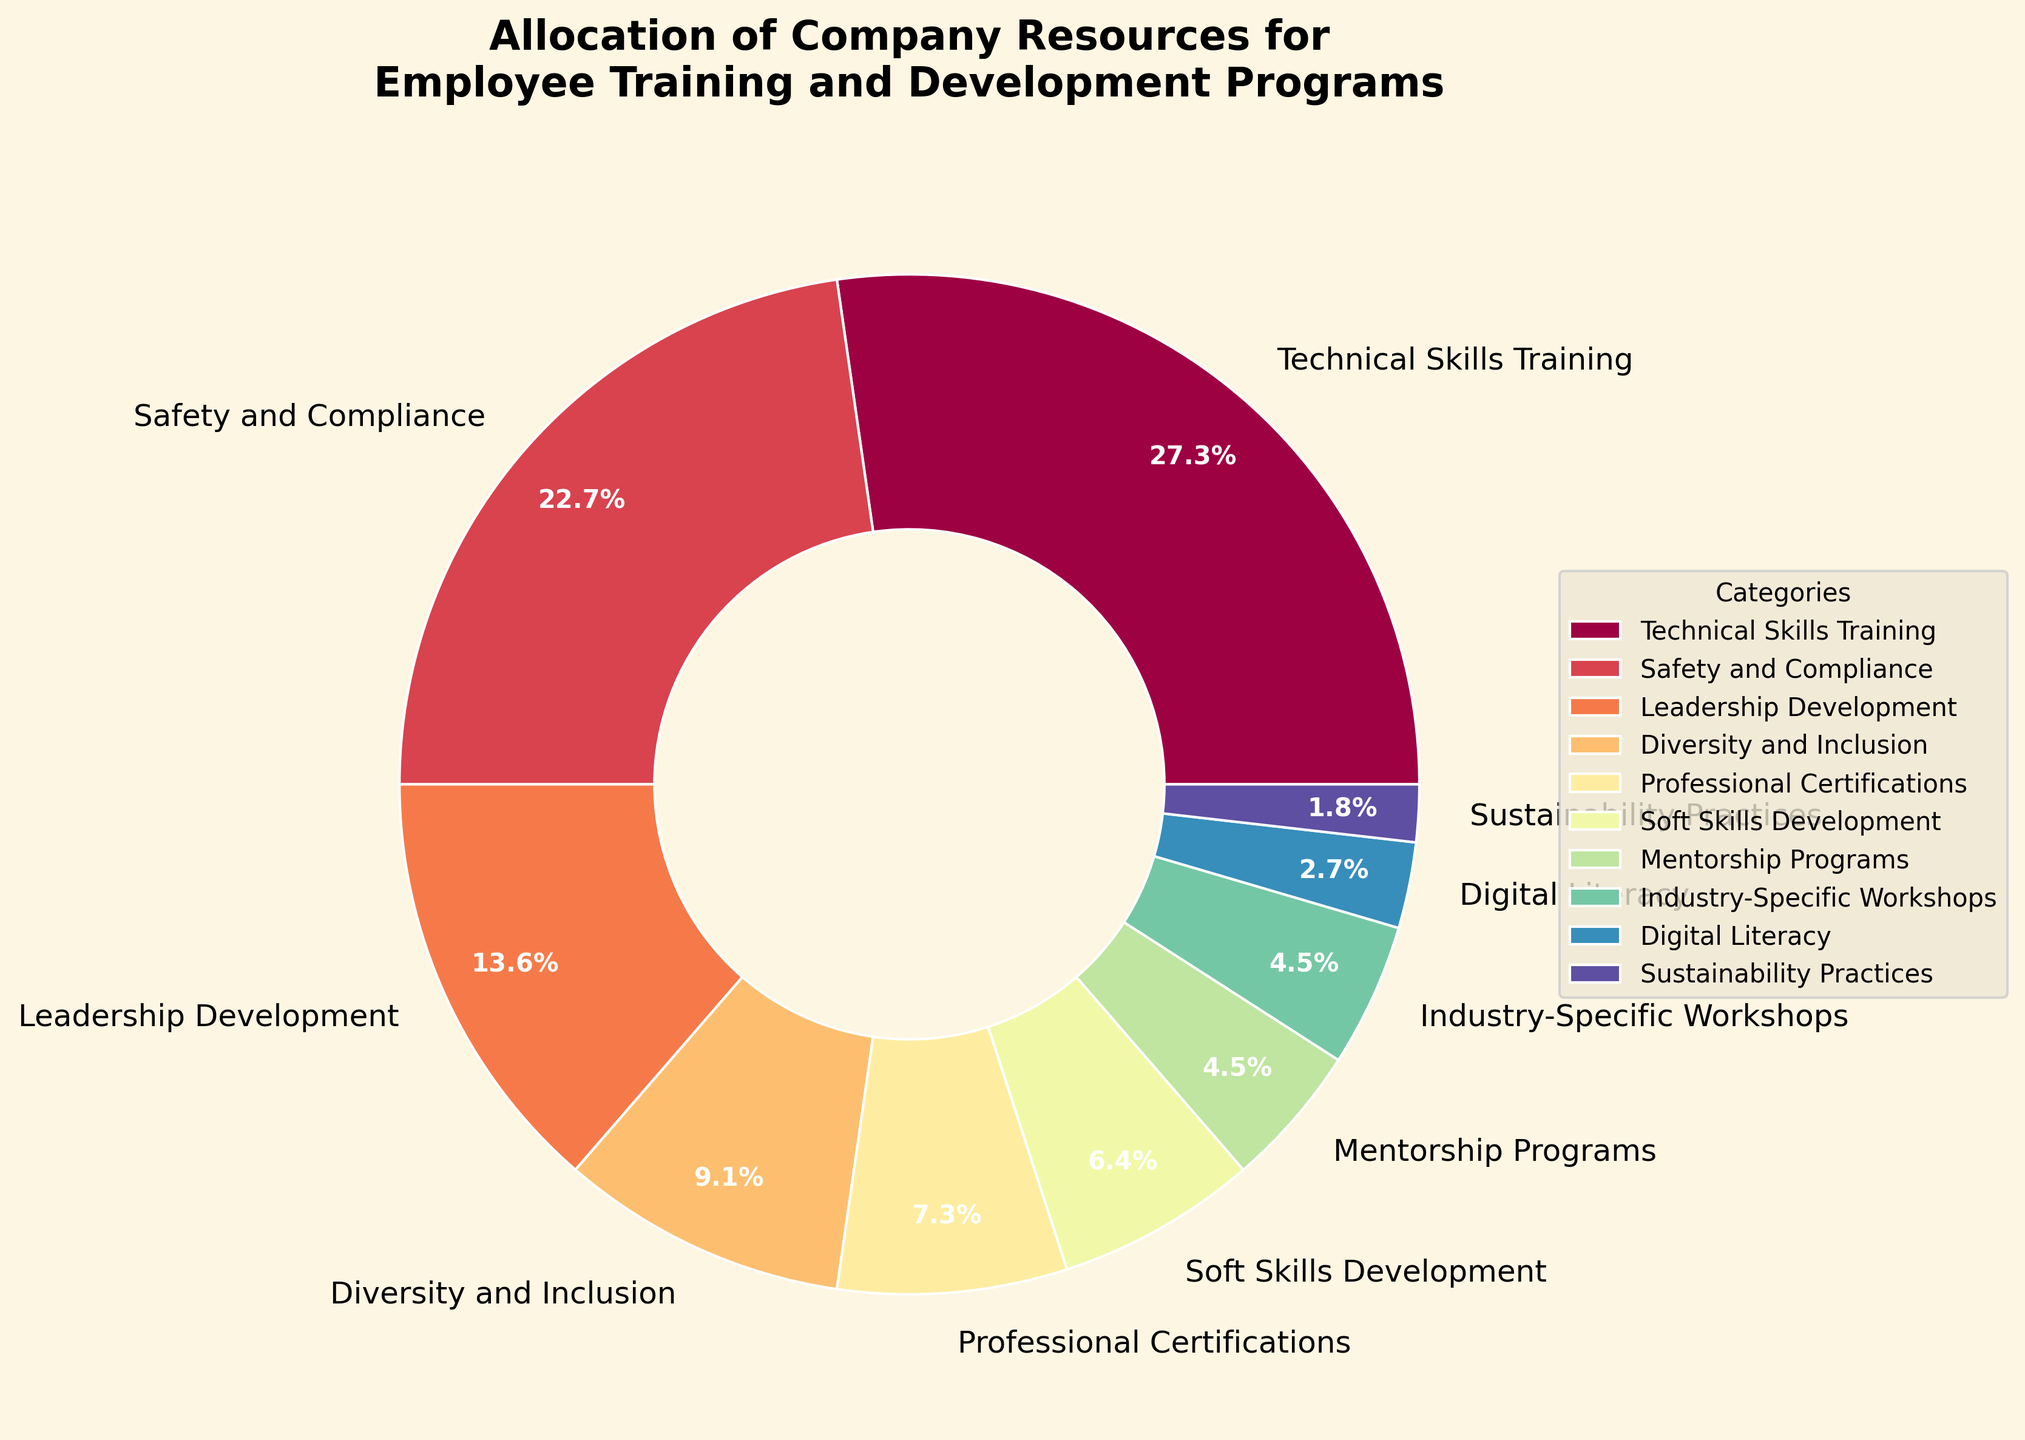What is the largest single category in the allocation of company resources for employee training? To find the largest category, look at each segment of the pie chart and identify the one with the highest percentage. The 'Technical Skills Training' segment is the largest.
Answer: Technical Skills Training Which two categories together make up 50% of the allocation? Check the pie chart to find two categories whose percentages add up to 50%. 'Technical Skills Training' at 30% and 'Safety and Compliance' at 25% together add up to 55%, which is above 50%. 'Technical Skills Training' at 30% and 'Leadership Development' at 15% together add up to 45%, which is below 50%. Finally, 'Technical Skills Training' at 30% and 'Safety and Compliance' at 25% together add up to 55%.
Answer: Technical Skills Training and Safety and Compliance Which category has the smallest allocation, and what is its percentage? Check the pie chart for the smallest segment. The 'Sustainability Practices' segment is the smallest.
Answer: Sustainability Practices, 2% How much more is allocated to Professional Certifications than Soft Skills Development? Find the segments for 'Professional Certifications' and 'Soft Skills Development' and subtract their percentages: 8% - 7% = 1%.
Answer: 1% What percentage is allocated to categories that focus on broader skills rather than specific technical skills or compliance? Sum the percentages for 'Soft Skills Development' (7%), 'Leadership Development' (15%), and 'Diversity and Inclusion' (10%): 7% + 15% + 10% = 32%.
Answer: 32% Out of the total allocation, how much more percentage does 'Technical Skills Training' receive compared to 'Industry-Specific Workshops' and 'Digital Literacy' combined? Find the 'Technical Skills Training' allocation (30%) and add the allocations for 'Industry-Specific Workshops' (5%) and 'Digital Literacy' (3%), then subtract the result from 'Technical Skills Training': 30% - (5% + 3%) = 30% - 8% = 22%.
Answer: 22% Compare the allocations for 'Leadership Development' and 'Diversity and Inclusion'. Which one is higher, and by how much? Find 'Leadership Development' (15%) and 'Diversity and Inclusion' (10%) then subtract: 15% - 10% = 5%.
Answer: Leadership Development, 5% How do 'Safety and Compliance' and 'Technical Skills Training' compare in terms of their resource allocation, and what is the percentage difference between them? Check the pie chart for 'Safety and Compliance' (25%) and 'Technical Skills Training' (30%), then find the difference: 30% - 25% = 5%.
Answer: Technical Skills Training is 5% higher What is the combined percentage allocated to 'Mentorship Programs' and 'Industry-Specific Workshops'? Find the percentages for 'Mentorship Programs' (5%) and 'Industry-Specific Workshops' (5%) and sum them up: 5% + 5% = 10%.
Answer: 10% How does the allocation for 'Soft Skills Development' compare to 'Digital Literacy'? Check the pie chart for 'Soft Skills Development' (7%) and 'Digital Literacy' (3%), then find the difference: 7% - 3% = 4%.
Answer: Soft Skills Development is 4% higher 